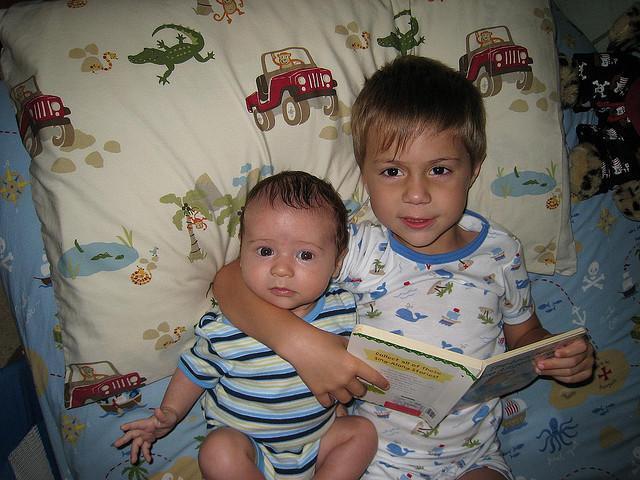How many people are there?
Give a very brief answer. 2. 